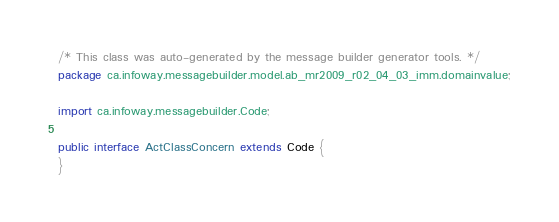<code> <loc_0><loc_0><loc_500><loc_500><_Java_>/* This class was auto-generated by the message builder generator tools. */
package ca.infoway.messagebuilder.model.ab_mr2009_r02_04_03_imm.domainvalue;

import ca.infoway.messagebuilder.Code;

public interface ActClassConcern extends Code {
}
</code> 